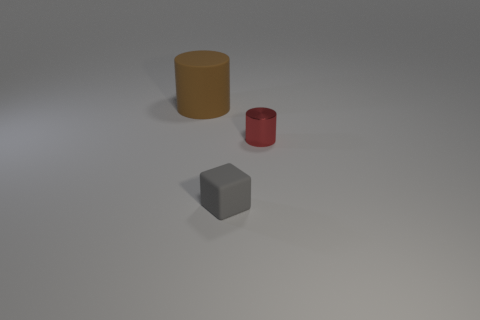Add 2 matte cubes. How many objects exist? 5 Subtract all blocks. How many objects are left? 2 Subtract all tiny gray matte cubes. Subtract all big matte cylinders. How many objects are left? 1 Add 3 red metallic things. How many red metallic things are left? 4 Add 3 red cylinders. How many red cylinders exist? 4 Subtract 0 yellow spheres. How many objects are left? 3 